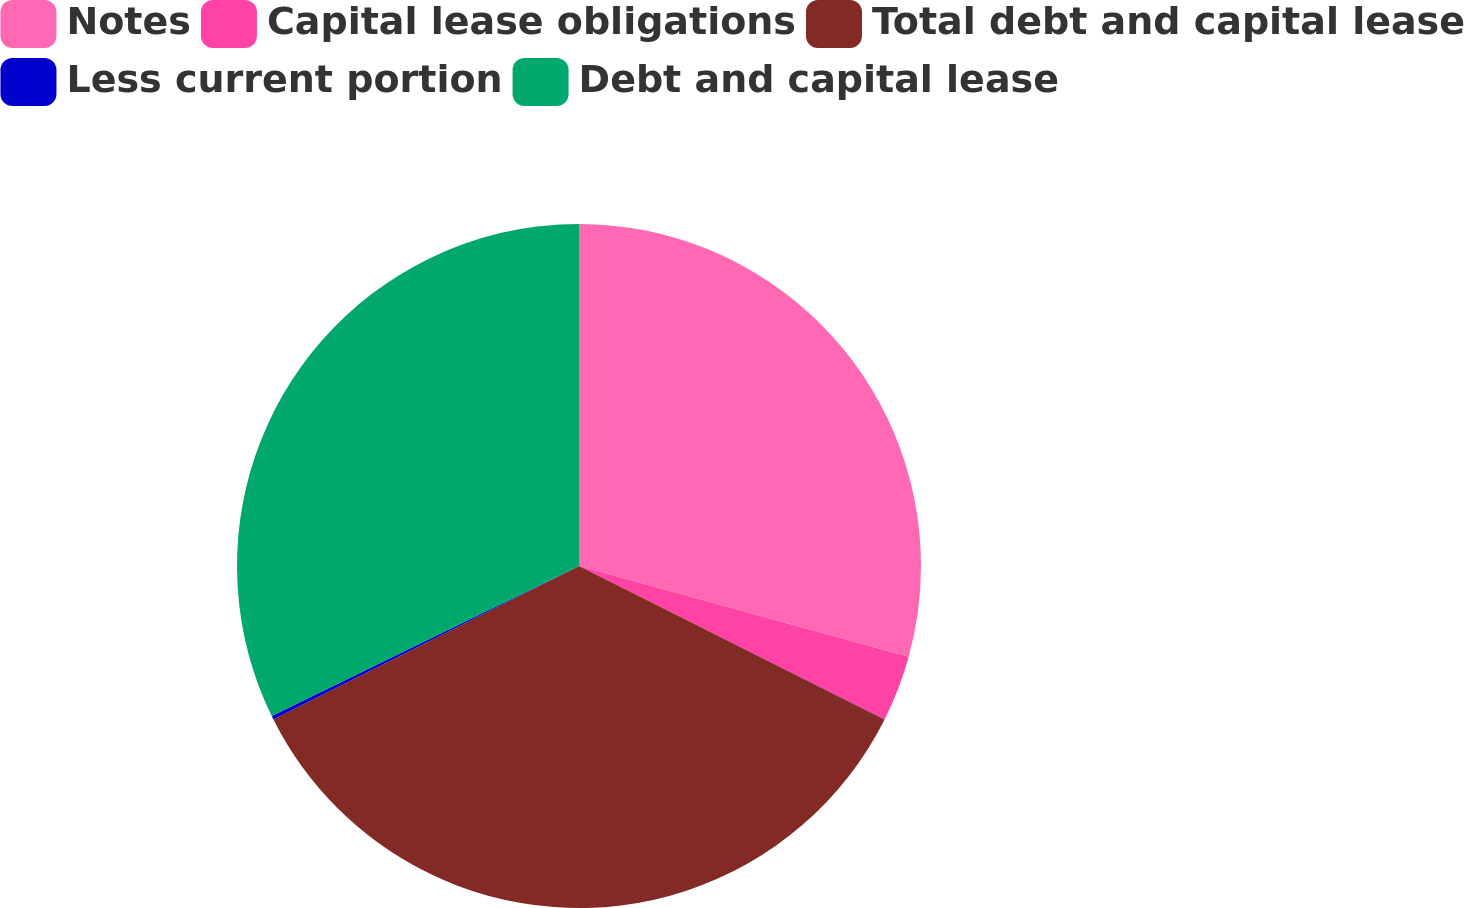Convert chart. <chart><loc_0><loc_0><loc_500><loc_500><pie_chart><fcel>Notes<fcel>Capital lease obligations<fcel>Total debt and capital lease<fcel>Less current portion<fcel>Debt and capital lease<nl><fcel>29.28%<fcel>3.13%<fcel>35.18%<fcel>0.18%<fcel>32.23%<nl></chart> 